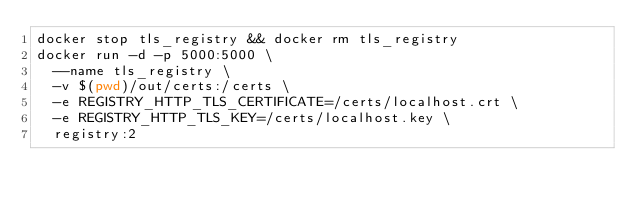<code> <loc_0><loc_0><loc_500><loc_500><_Bash_>docker stop tls_registry && docker rm tls_registry
docker run -d -p 5000:5000 \
  --name tls_registry \
  -v $(pwd)/out/certs:/certs \
  -e REGISTRY_HTTP_TLS_CERTIFICATE=/certs/localhost.crt \
  -e REGISTRY_HTTP_TLS_KEY=/certs/localhost.key \
  registry:2
</code> 